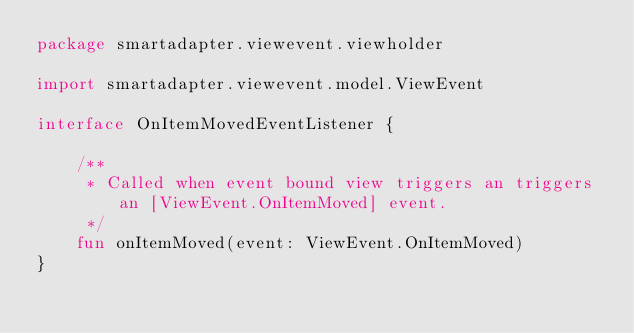<code> <loc_0><loc_0><loc_500><loc_500><_Kotlin_>package smartadapter.viewevent.viewholder

import smartadapter.viewevent.model.ViewEvent

interface OnItemMovedEventListener {

    /**
     * Called when event bound view triggers an triggers an [ViewEvent.OnItemMoved] event.
     */
    fun onItemMoved(event: ViewEvent.OnItemMoved)
}
</code> 